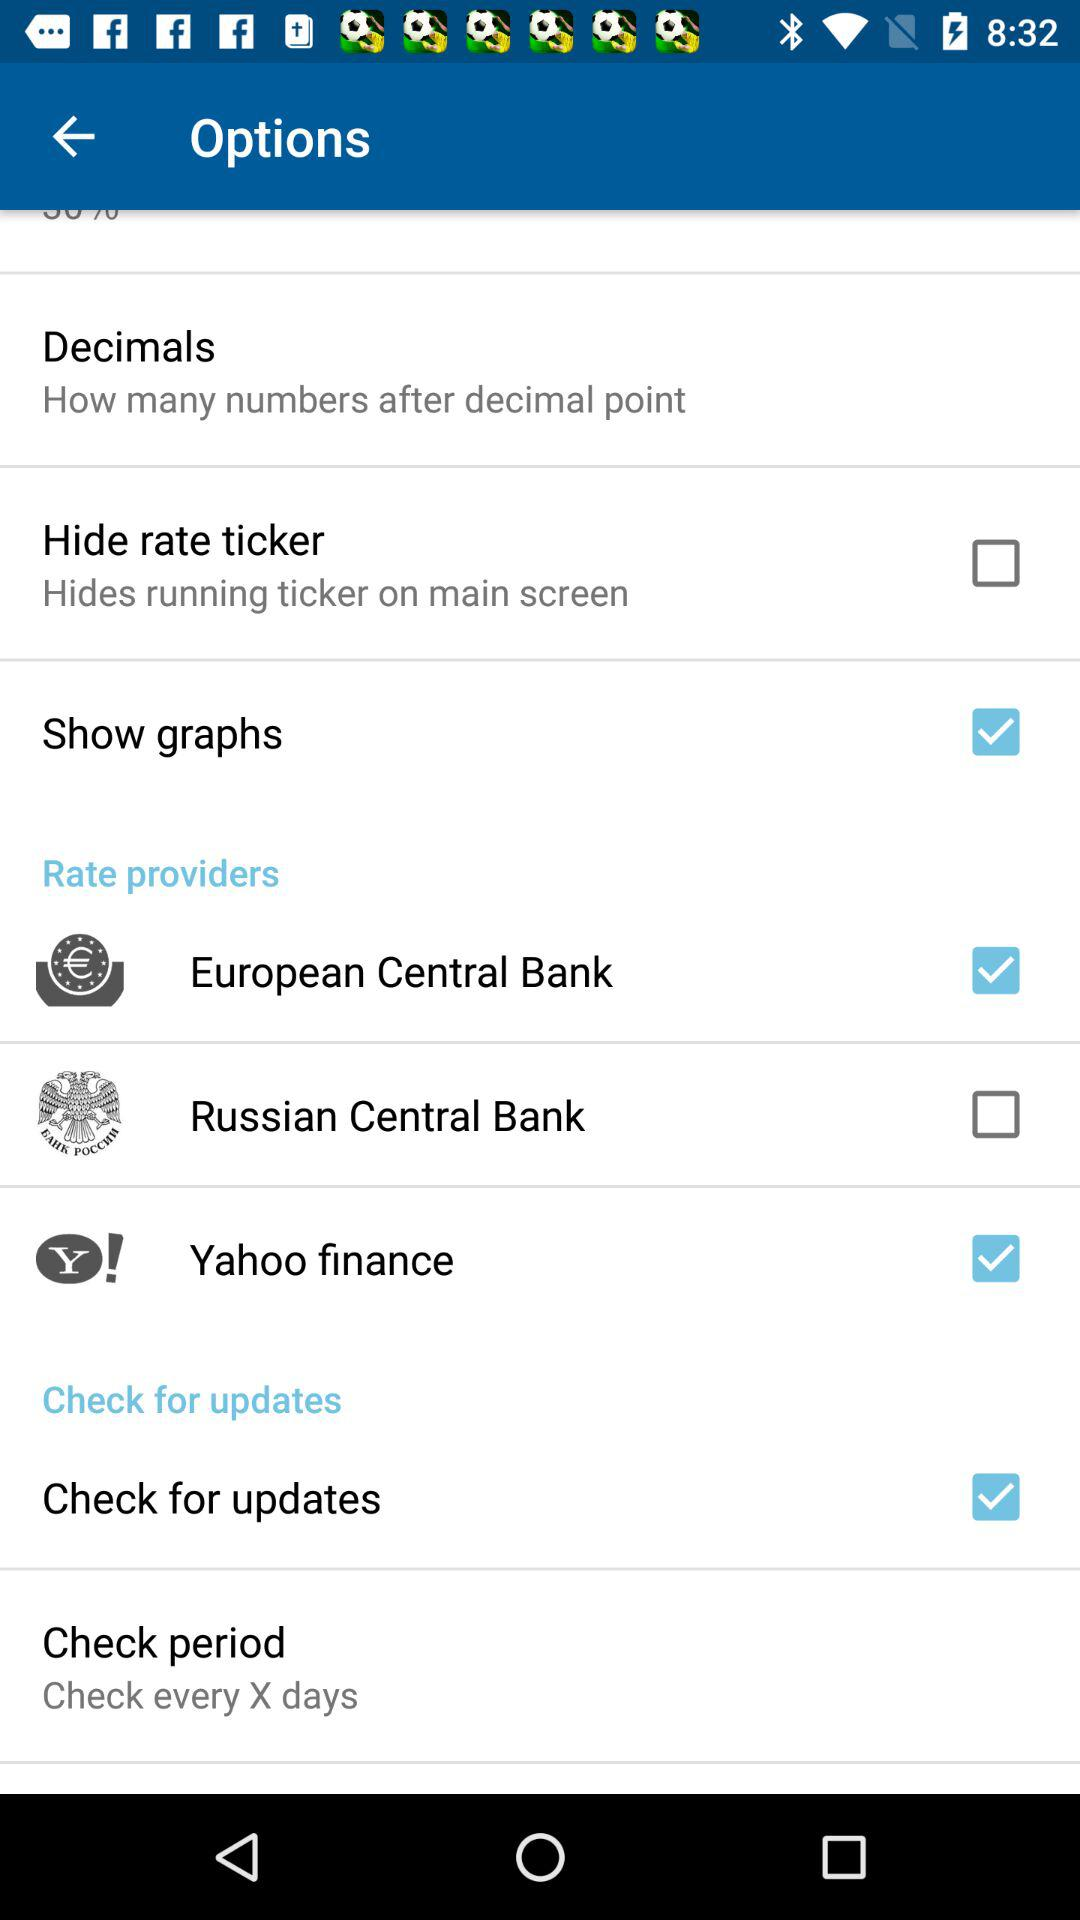What is the status of "Yahoo finance"? The status is "on". 